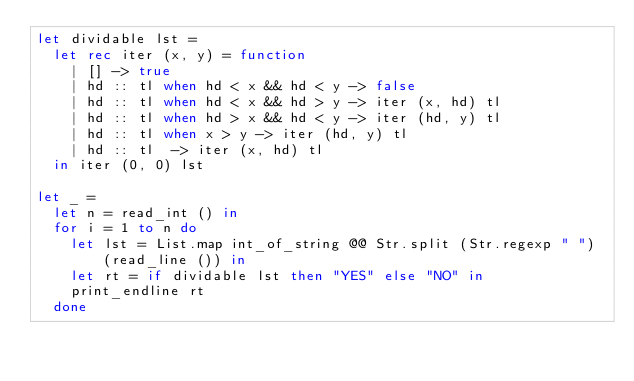<code> <loc_0><loc_0><loc_500><loc_500><_OCaml_>let dividable lst =
  let rec iter (x, y) = function
    | [] -> true
    | hd :: tl when hd < x && hd < y -> false
    | hd :: tl when hd < x && hd > y -> iter (x, hd) tl
    | hd :: tl when hd > x && hd < y -> iter (hd, y) tl
    | hd :: tl when x > y -> iter (hd, y) tl
    | hd :: tl  -> iter (x, hd) tl
  in iter (0, 0) lst
                                             
let _ = 
  let n = read_int () in
  for i = 1 to n do
    let lst = List.map int_of_string @@ Str.split (Str.regexp " ") (read_line ()) in
    let rt = if dividable lst then "YES" else "NO" in
    print_endline rt
  done</code> 